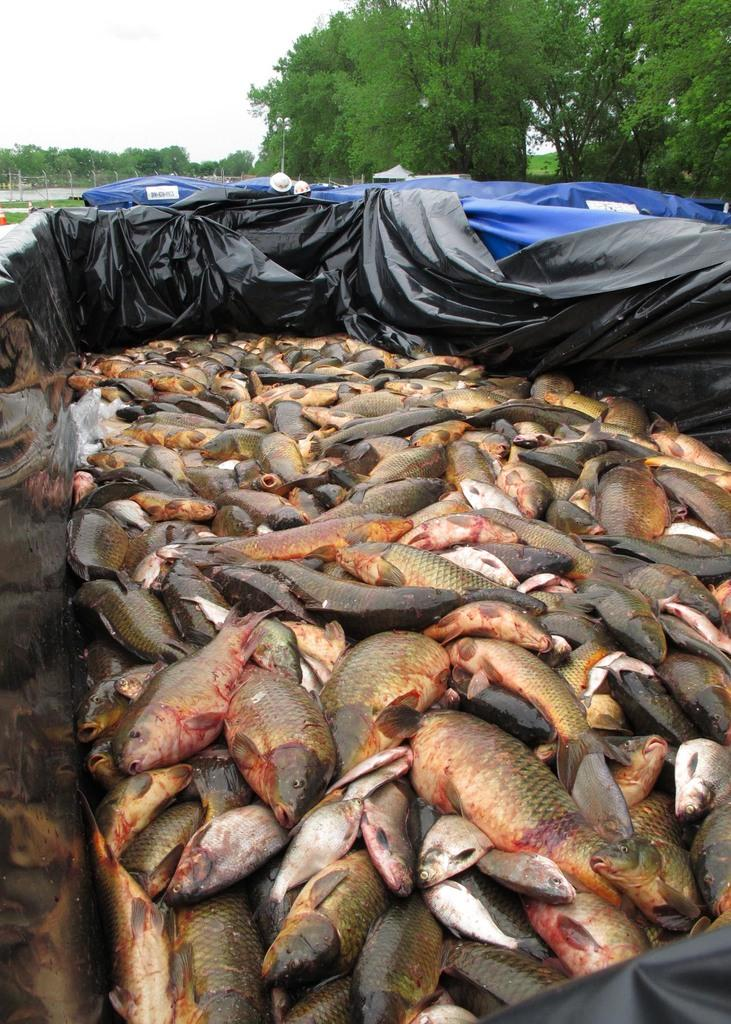What type of animals can be seen in the image? There are fishes in the image. What is the color of the cover that contains the fishes? The fishes are in a black color cover. What can be seen in the background of the image? There are trees and the sky visible in the background of the image. What type of glove can be seen hanging on the tree in the image? There is no glove present in the image; it only features fishes in a black cover, trees, and the sky in the background. 